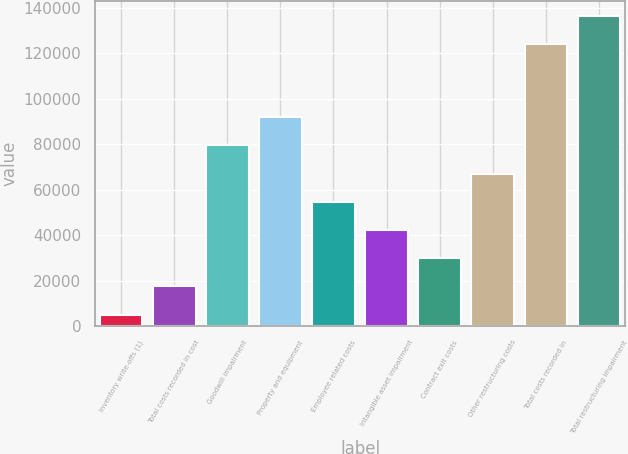Convert chart. <chart><loc_0><loc_0><loc_500><loc_500><bar_chart><fcel>Inventory write-offs (1)<fcel>Total costs recorded in cost<fcel>Goodwill impairment<fcel>Property and equipment<fcel>Employee related costs<fcel>Intangible asset impairment<fcel>Contract exit costs<fcel>Other restructuring costs<fcel>Total costs recorded in<fcel>Total restructuring impairment<nl><fcel>5077<fcel>17481.9<fcel>79506.4<fcel>91911.3<fcel>54696.6<fcel>42291.7<fcel>29886.8<fcel>67101.5<fcel>124049<fcel>136454<nl></chart> 